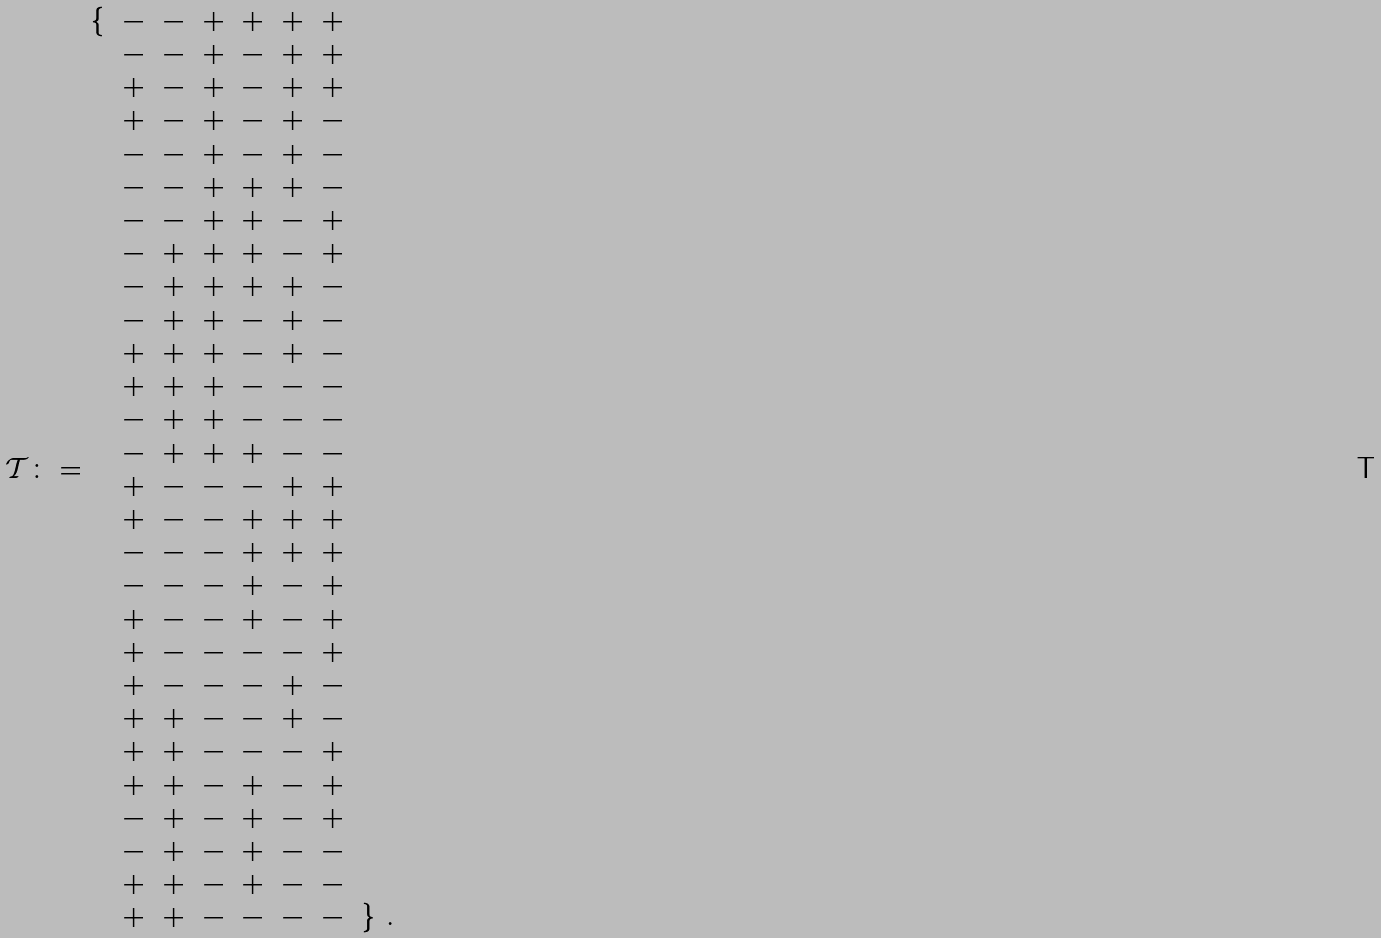<formula> <loc_0><loc_0><loc_500><loc_500>\mathcal { T } \colon = \begin{matrix} \{ & - & - & + & + & + & + \\ & - & - & + & - & + & + \\ & + & - & + & - & + & + \\ & + & - & + & - & + & - & \\ & - & - & + & - & + & - \\ & - & - & + & + & + & - \\ & - & - & + & + & - & + \\ & - & + & + & + & - & + & \\ & - & + & + & + & + & - \\ & - & + & + & - & + & - \\ & + & + & + & - & + & - \\ & + & + & + & - & - & - & \\ & - & + & + & - & - & - \\ & - & + & + & + & - & - \\ & + & - & - & - & + & + \\ & + & - & - & + & + & + & \\ & - & - & - & + & + & + \\ & - & - & - & + & - & + \\ & + & - & - & + & - & + \\ & + & - & - & - & - & + & \\ & + & - & - & - & + & - \\ & + & + & - & - & + & - \\ & + & + & - & - & - & + \\ & + & + & - & + & - & + & \\ & - & + & - & + & - & + \\ & - & + & - & + & - & - \\ & + & + & - & + & - & - \\ & + & + & - & - & - & - & \} \ . \end{matrix}</formula> 